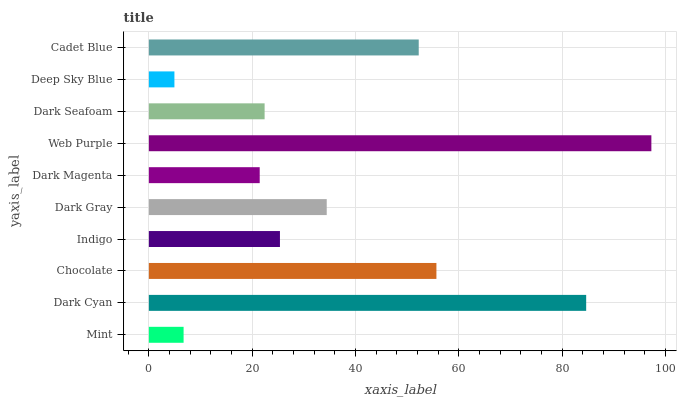Is Deep Sky Blue the minimum?
Answer yes or no. Yes. Is Web Purple the maximum?
Answer yes or no. Yes. Is Dark Cyan the minimum?
Answer yes or no. No. Is Dark Cyan the maximum?
Answer yes or no. No. Is Dark Cyan greater than Mint?
Answer yes or no. Yes. Is Mint less than Dark Cyan?
Answer yes or no. Yes. Is Mint greater than Dark Cyan?
Answer yes or no. No. Is Dark Cyan less than Mint?
Answer yes or no. No. Is Dark Gray the high median?
Answer yes or no. Yes. Is Indigo the low median?
Answer yes or no. Yes. Is Web Purple the high median?
Answer yes or no. No. Is Chocolate the low median?
Answer yes or no. No. 